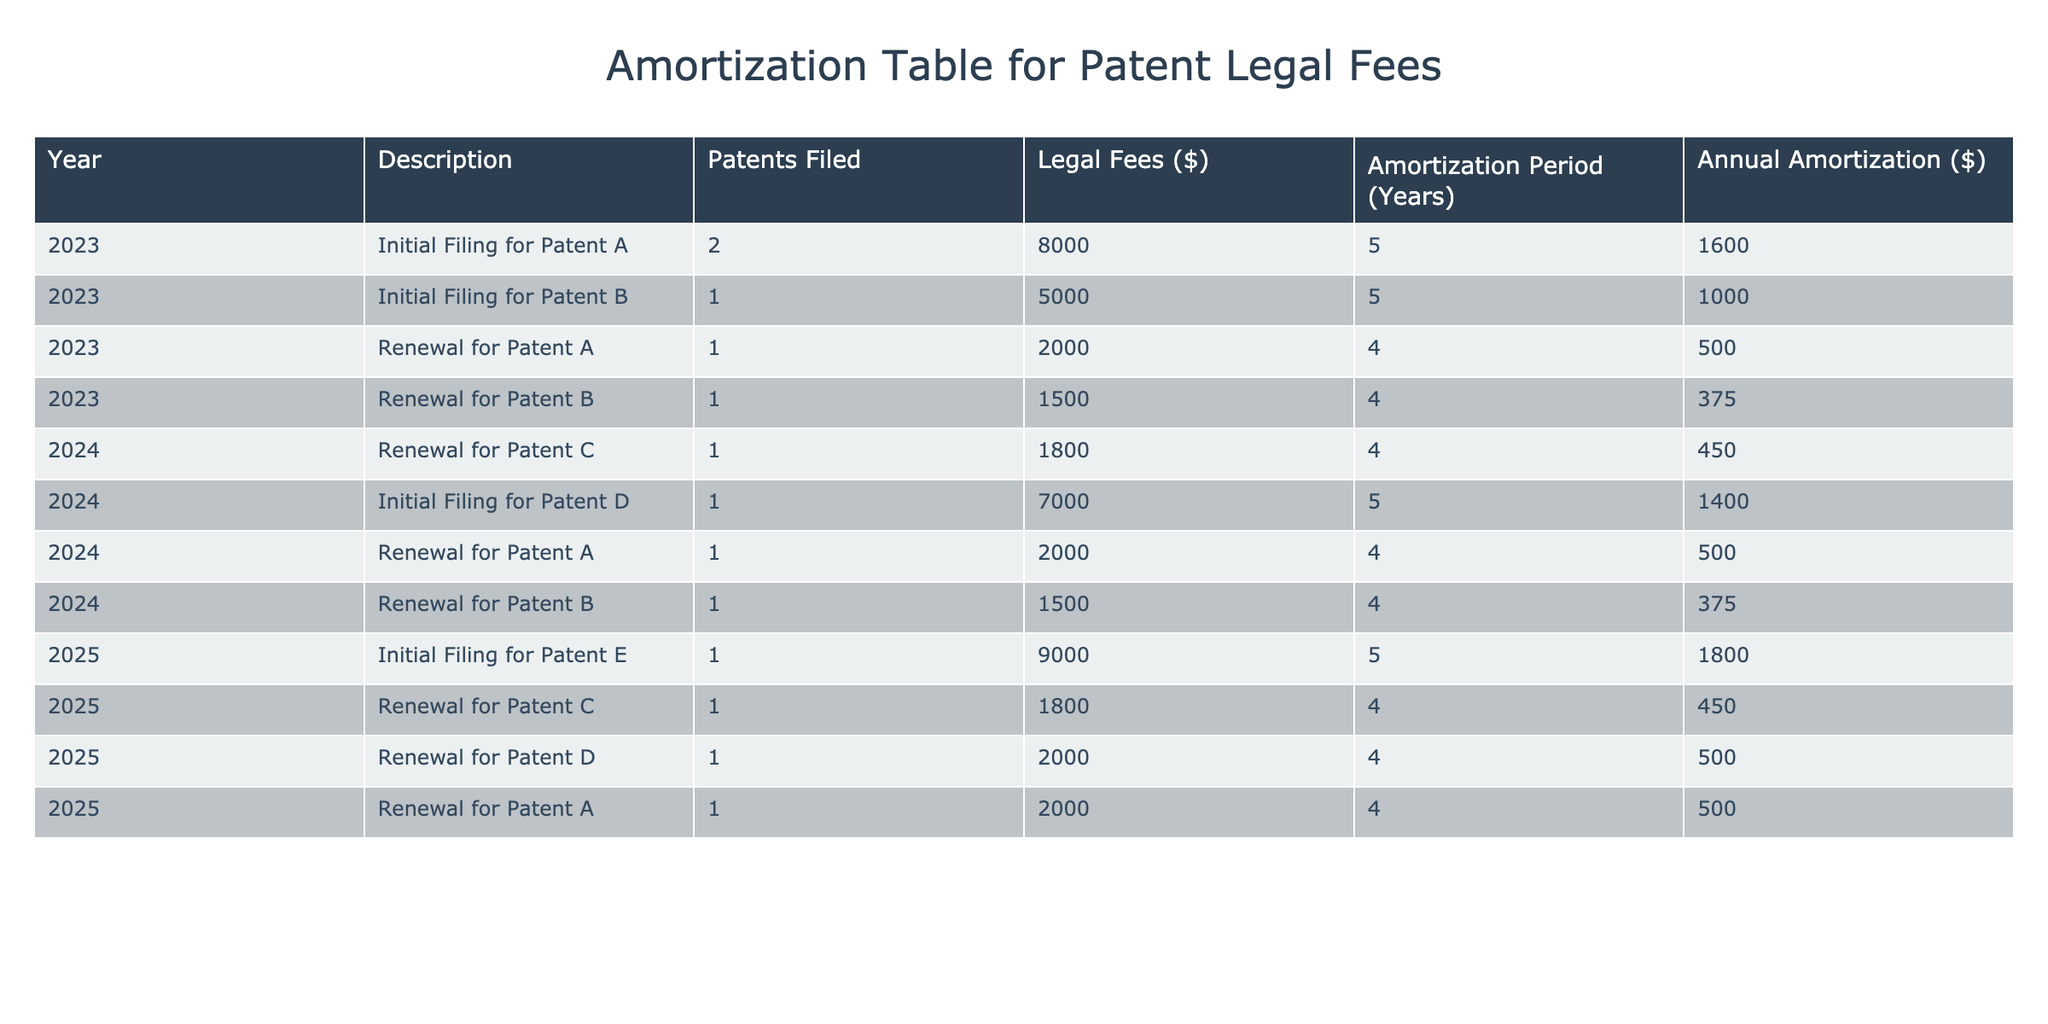What is the total legal fee for the initial filing of Patent A? To find the total legal fee for the initial filing of Patent A, we look at the "Legal Fees ($)" column for the "Initial Filing for Patent A" row, which shows a fee of 8000.
Answer: 8000 How many patents were filed in total for the year 2023? To find the total number of patents filed in 2023, we sum the "Patents Filed" column for each row in 2023: 2 (Patent A) + 1 (Patent B) = 3.
Answer: 3 What is the average annual amortization for all patents filed in 2024? First, we identify the annual amortization amounts for the patents filed in 2024: 450 (Renewal for Patent C), 1400 (Initial Filing for Patent D), 500 (Renewal for Patent A), and 375 (Renewal for Patent B). The sum is 450 + 1400 + 500 + 375 = 2725. We have 4 entries, so the average is 2725 / 4 = 681.25.
Answer: 681.25 Did the legal fees for the renewal of Patent B increase from 2023 to 2024? We compare the legal fees for the renewal of Patent B in both years. In 2023, the fee was 1500, and in 2024, it was also 1500. Since 1500 equals 1500, there was no increase.
Answer: No What is the total annual amortization for all patents filed in 2023? To find the total annual amortization for 2023, we add the annual amortization for each row in that year: 1600 (Patent A) + 1000 (Patent B) + 500 (Renewal for Patent A) + 375 (Renewal for Patent B) = 3475.
Answer: 3475 Which patent had the highest legal fee recorded and what was that amount? Upon examining the "Legal Fees ($)" column, the initial filing for Patent E in 2025 shows the highest fee recorded at 9000.
Answer: 9000 What is the total legal fee for renewals in 2025? In 2025, the renewals include: 450 (Renewal for Patent C), 500 (Renewal for Patent D), and 500 (Renewal for Patent A). The total is 450 + 500 + 500 = 1450.
Answer: 1450 Are the legal fees for the renewal of Patent A the same in all years? The legal fees for the renewal of Patent A are as follows: 500 in 2023, 500 in 2024, and 500 in 2025. Since all values are equal, they are the same.
Answer: Yes 